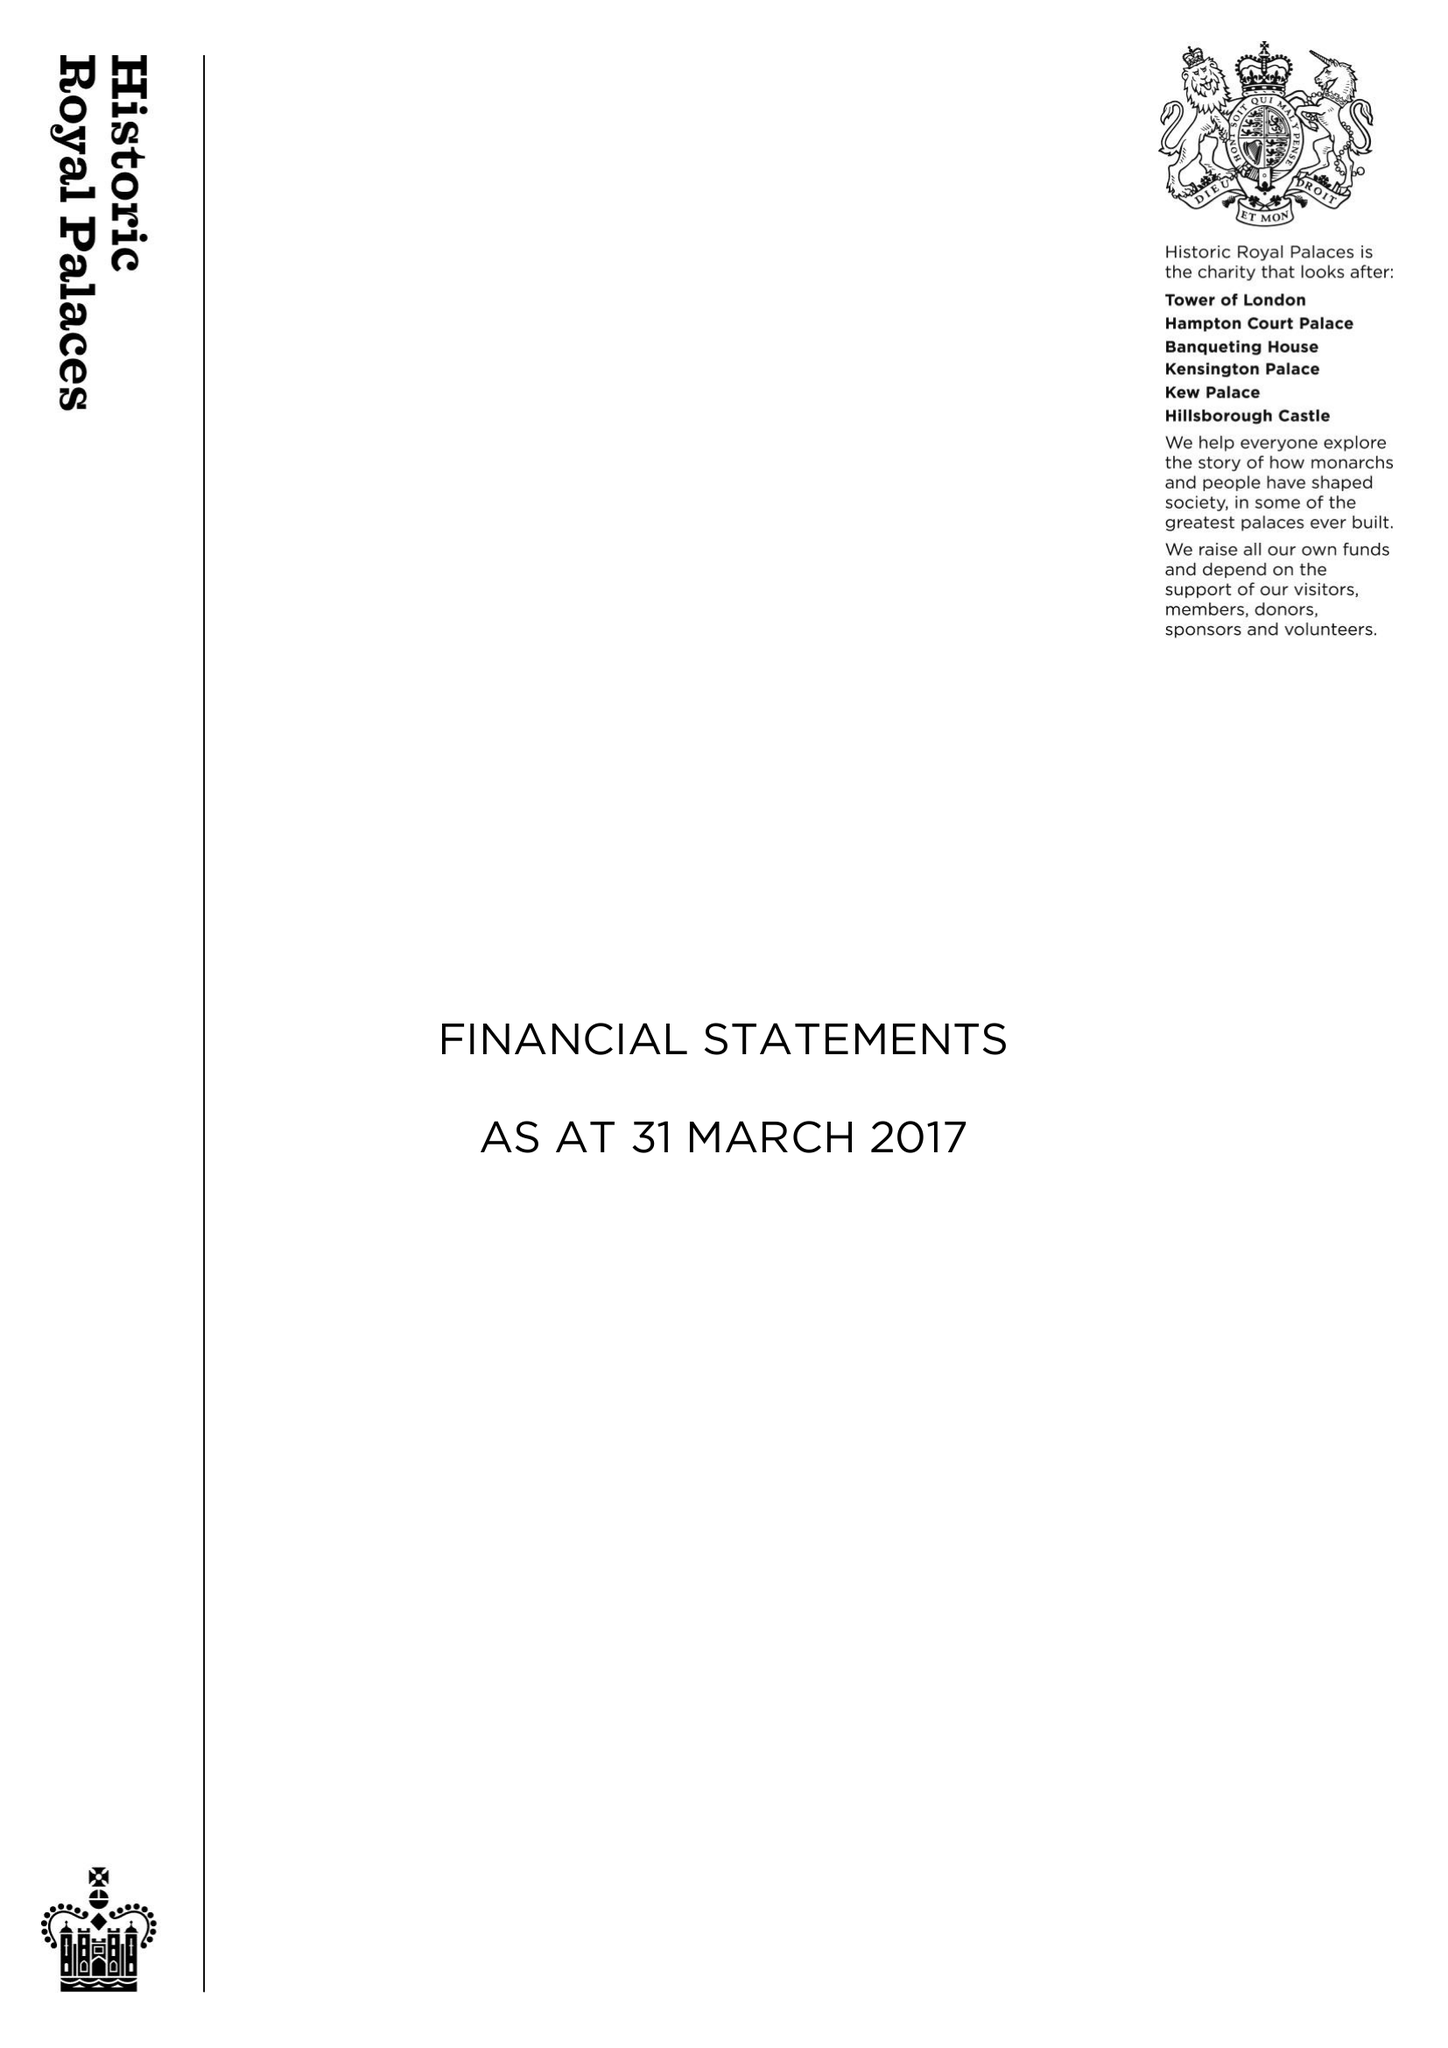What is the value for the spending_annually_in_british_pounds?
Answer the question using a single word or phrase. 85854000.00 